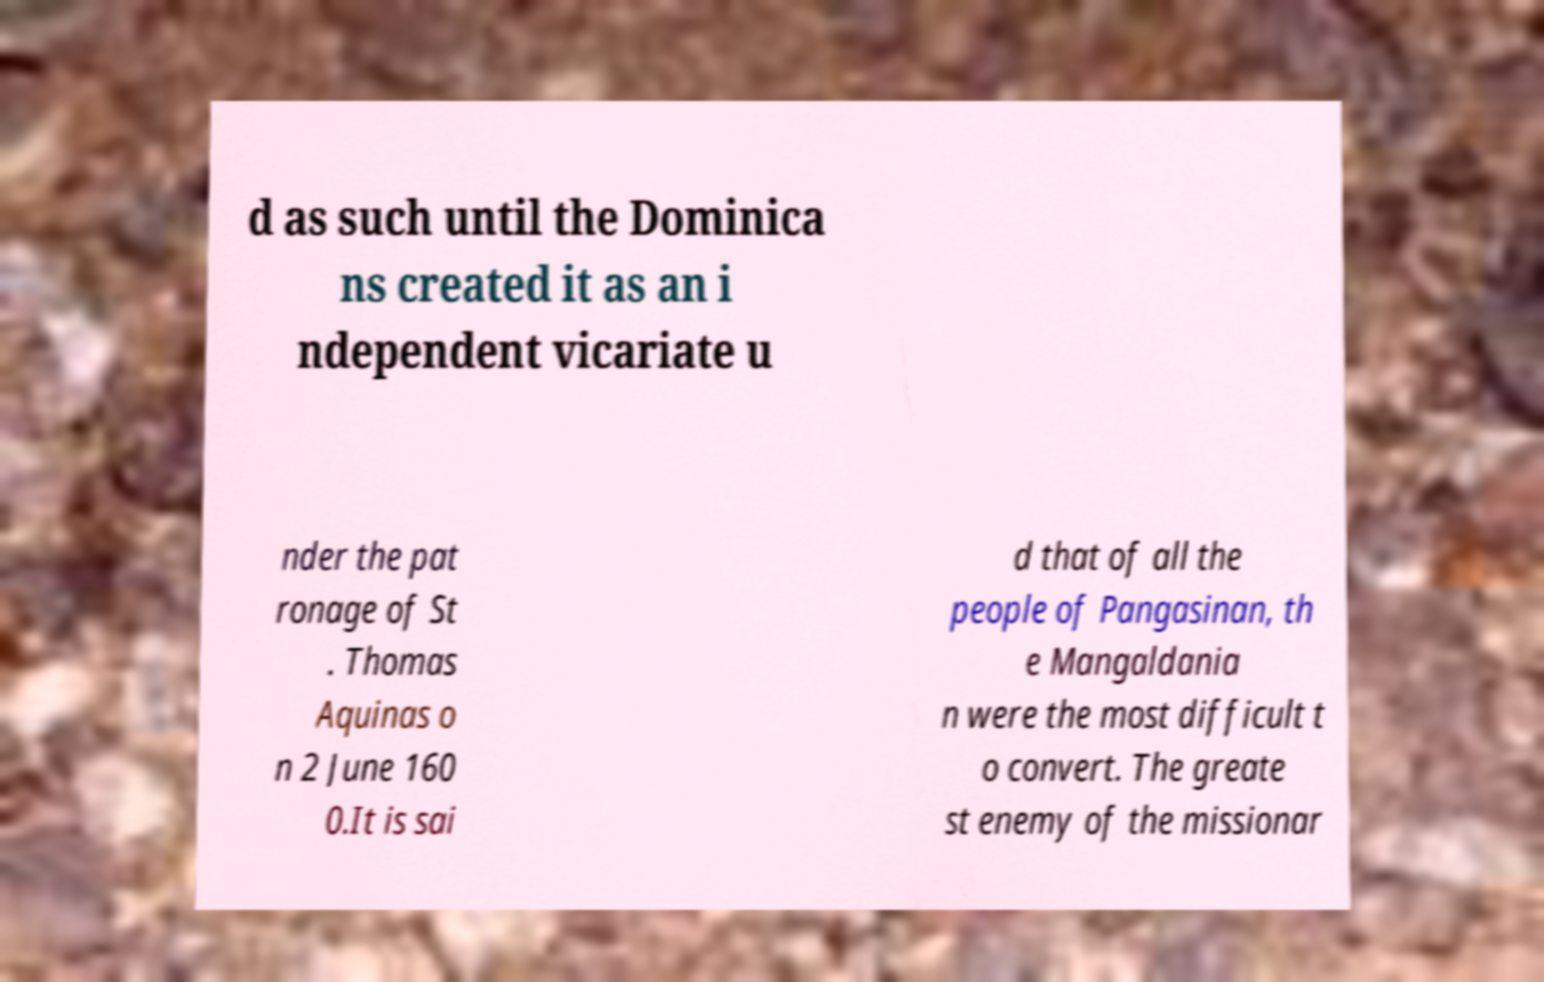Could you assist in decoding the text presented in this image and type it out clearly? d as such until the Dominica ns created it as an i ndependent vicariate u nder the pat ronage of St . Thomas Aquinas o n 2 June 160 0.It is sai d that of all the people of Pangasinan, th e Mangaldania n were the most difficult t o convert. The greate st enemy of the missionar 